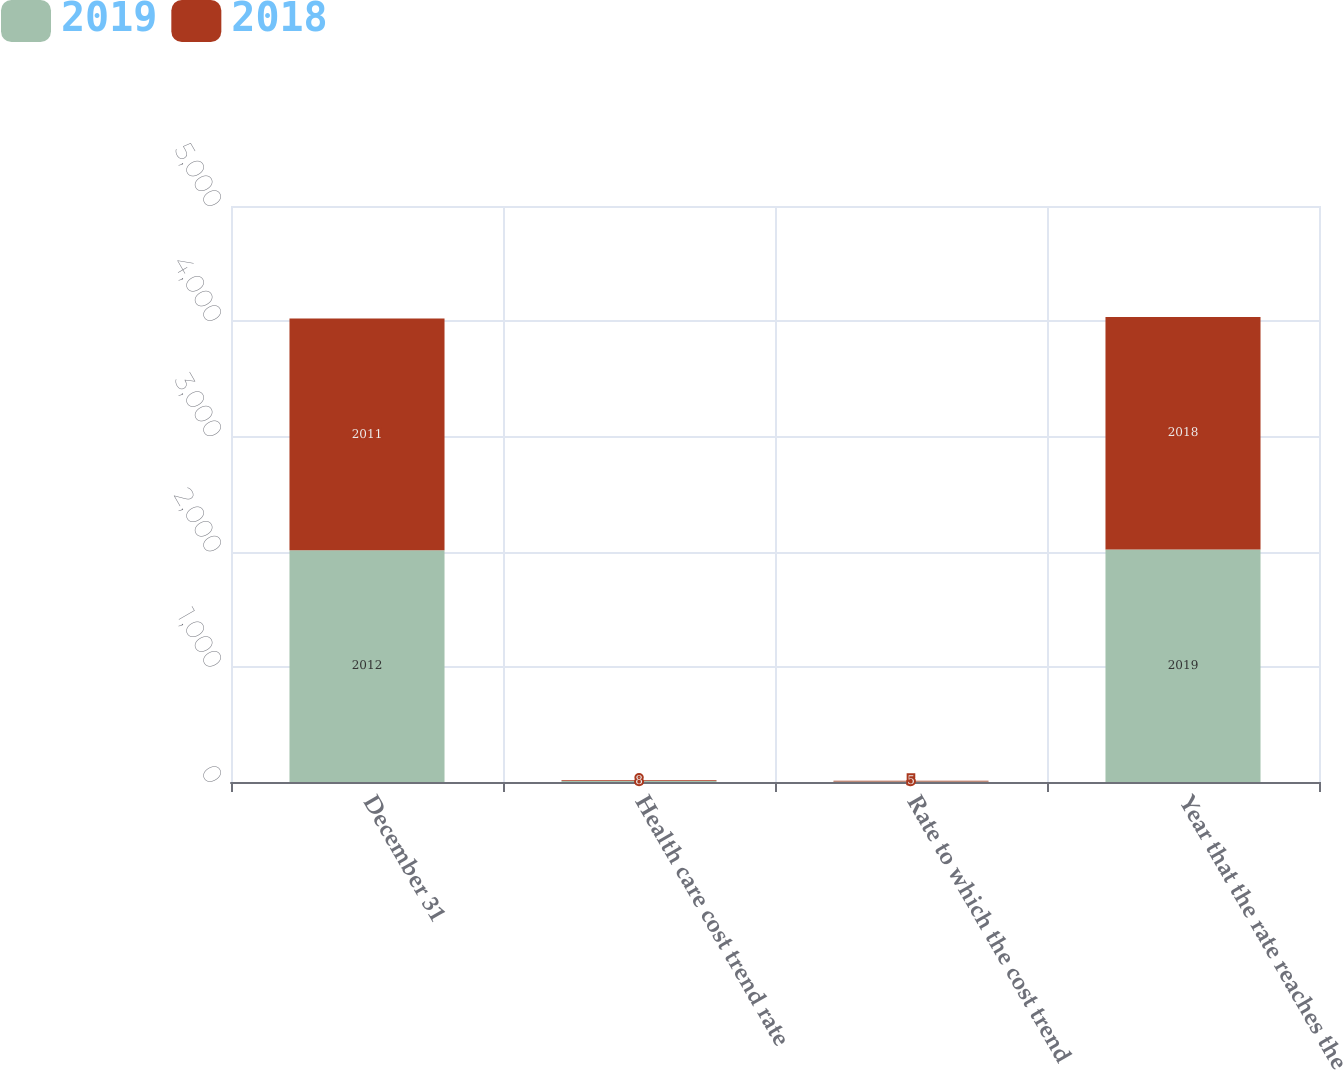Convert chart. <chart><loc_0><loc_0><loc_500><loc_500><stacked_bar_chart><ecel><fcel>December 31<fcel>Health care cost trend rate<fcel>Rate to which the cost trend<fcel>Year that the rate reaches the<nl><fcel>2019<fcel>2012<fcel>8<fcel>5<fcel>2019<nl><fcel>2018<fcel>2011<fcel>8<fcel>5<fcel>2018<nl></chart> 